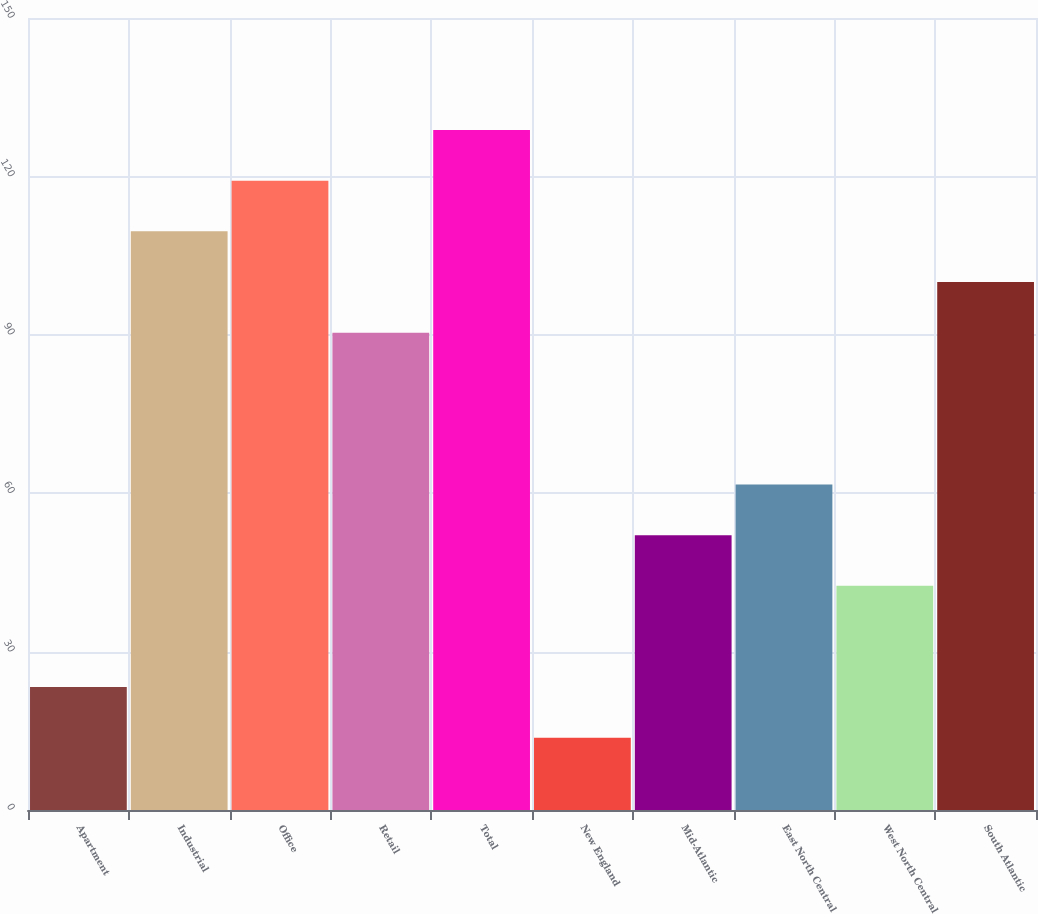Convert chart to OTSL. <chart><loc_0><loc_0><loc_500><loc_500><bar_chart><fcel>Apartment<fcel>Industrial<fcel>Office<fcel>Retail<fcel>Total<fcel>New England<fcel>Mid-Atlantic<fcel>East North Central<fcel>West North Central<fcel>South Atlantic<nl><fcel>23.28<fcel>109.59<fcel>119.18<fcel>90.41<fcel>128.77<fcel>13.69<fcel>52.05<fcel>61.64<fcel>42.46<fcel>100<nl></chart> 